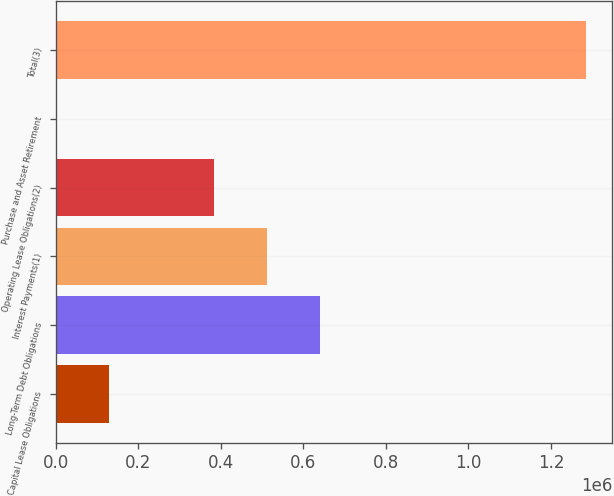Convert chart to OTSL. <chart><loc_0><loc_0><loc_500><loc_500><bar_chart><fcel>Capital Lease Obligations<fcel>Long-Term Debt Obligations<fcel>Interest Payments(1)<fcel>Operating Lease Obligations(2)<fcel>Purchase and Asset Retirement<fcel>Total(3)<nl><fcel>129419<fcel>640371<fcel>511995<fcel>383619<fcel>1043<fcel>1.2848e+06<nl></chart> 